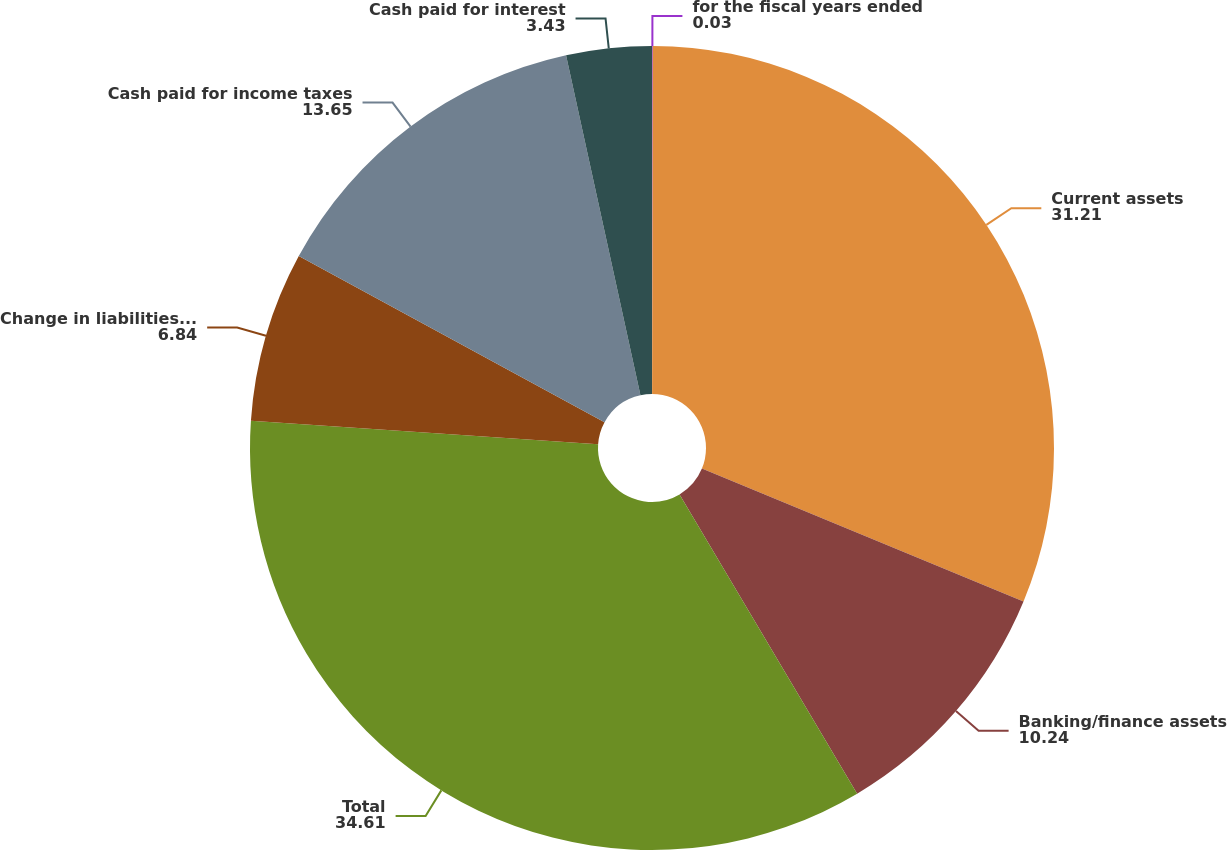Convert chart to OTSL. <chart><loc_0><loc_0><loc_500><loc_500><pie_chart><fcel>for the fiscal years ended<fcel>Current assets<fcel>Banking/finance assets<fcel>Total<fcel>Change in liabilities related<fcel>Cash paid for income taxes<fcel>Cash paid for interest<nl><fcel>0.03%<fcel>31.21%<fcel>10.24%<fcel>34.61%<fcel>6.84%<fcel>13.65%<fcel>3.43%<nl></chart> 